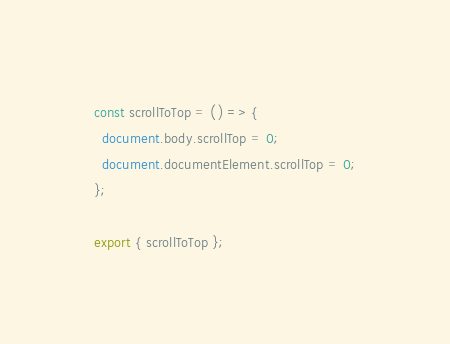<code> <loc_0><loc_0><loc_500><loc_500><_JavaScript_>const scrollToTop = () => {
  document.body.scrollTop = 0;
  document.documentElement.scrollTop = 0;
};

export { scrollToTop };
</code> 